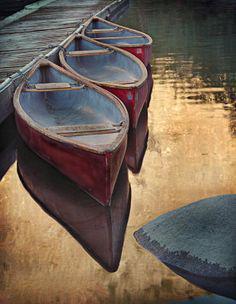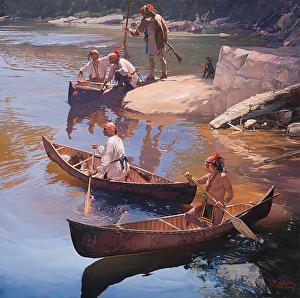The first image is the image on the left, the second image is the image on the right. Considering the images on both sides, is "One image shows at least three empty red canoes parked close together on water, and the other image includes at least one oar." valid? Answer yes or no. Yes. 